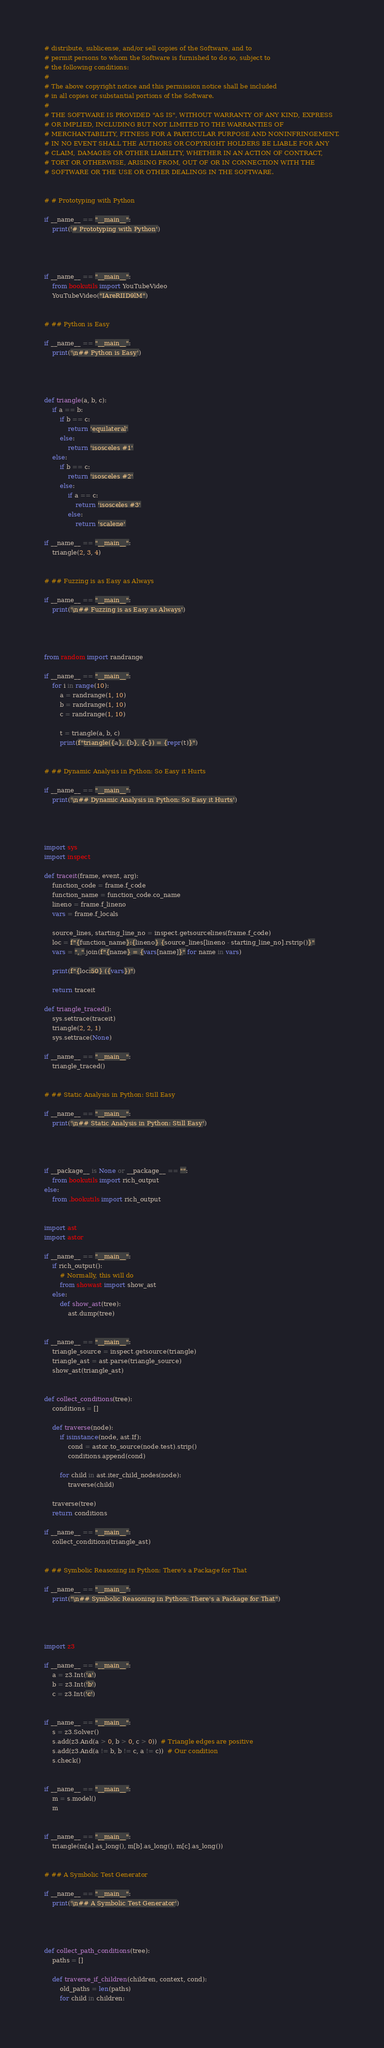<code> <loc_0><loc_0><loc_500><loc_500><_Python_># distribute, sublicense, and/or sell copies of the Software, and to
# permit persons to whom the Software is furnished to do so, subject to
# the following conditions:
#
# The above copyright notice and this permission notice shall be included
# in all copies or substantial portions of the Software.
#
# THE SOFTWARE IS PROVIDED "AS IS", WITHOUT WARRANTY OF ANY KIND, EXPRESS
# OR IMPLIED, INCLUDING BUT NOT LIMITED TO THE WARRANTIES OF
# MERCHANTABILITY, FITNESS FOR A PARTICULAR PURPOSE AND NONINFRINGEMENT.
# IN NO EVENT SHALL THE AUTHORS OR COPYRIGHT HOLDERS BE LIABLE FOR ANY
# CLAIM, DAMAGES OR OTHER LIABILITY, WHETHER IN AN ACTION OF CONTRACT,
# TORT OR OTHERWISE, ARISING FROM, OUT OF OR IN CONNECTION WITH THE
# SOFTWARE OR THE USE OR OTHER DEALINGS IN THE SOFTWARE.


# # Prototyping with Python

if __name__ == "__main__":
    print('# Prototyping with Python')




if __name__ == "__main__":
    from bookutils import YouTubeVideo
    YouTubeVideo("IAreRIID9lM")


# ## Python is Easy

if __name__ == "__main__":
    print('\n## Python is Easy')




def triangle(a, b, c):
    if a == b:
        if b == c:
            return 'equilateral'
        else:
            return 'isosceles #1'
    else:
        if b == c:
            return 'isosceles #2'
        else:
            if a == c:
                return 'isosceles #3'
            else:
                return 'scalene'

if __name__ == "__main__":
    triangle(2, 3, 4)


# ## Fuzzing is as Easy as Always

if __name__ == "__main__":
    print('\n## Fuzzing is as Easy as Always')




from random import randrange

if __name__ == "__main__":
    for i in range(10):
        a = randrange(1, 10)
        b = randrange(1, 10)
        c = randrange(1, 10)

        t = triangle(a, b, c)
        print(f"triangle({a}, {b}, {c}) = {repr(t)}")


# ## Dynamic Analysis in Python: So Easy it Hurts

if __name__ == "__main__":
    print('\n## Dynamic Analysis in Python: So Easy it Hurts')




import sys
import inspect

def traceit(frame, event, arg):
    function_code = frame.f_code
    function_name = function_code.co_name
    lineno = frame.f_lineno
    vars = frame.f_locals

    source_lines, starting_line_no = inspect.getsourcelines(frame.f_code)
    loc = f"{function_name}:{lineno} {source_lines[lineno - starting_line_no].rstrip()}"
    vars = ", ".join(f"{name} = {vars[name]}" for name in vars)

    print(f"{loc:50} ({vars})")

    return traceit

def triangle_traced():
    sys.settrace(traceit)
    triangle(2, 2, 1)
    sys.settrace(None)

if __name__ == "__main__":
    triangle_traced()


# ## Static Analysis in Python: Still Easy

if __name__ == "__main__":
    print('\n## Static Analysis in Python: Still Easy')




if __package__ is None or __package__ == "":
    from bookutils import rich_output
else:
    from .bookutils import rich_output


import ast
import astor

if __name__ == "__main__":
    if rich_output():
        # Normally, this will do
        from showast import show_ast
    else:
        def show_ast(tree):
            ast.dump(tree)


if __name__ == "__main__":
    triangle_source = inspect.getsource(triangle)
    triangle_ast = ast.parse(triangle_source)
    show_ast(triangle_ast)


def collect_conditions(tree):
    conditions = []

    def traverse(node):
        if isinstance(node, ast.If):
            cond = astor.to_source(node.test).strip()
            conditions.append(cond)

        for child in ast.iter_child_nodes(node):
            traverse(child)

    traverse(tree)
    return conditions

if __name__ == "__main__":
    collect_conditions(triangle_ast)


# ## Symbolic Reasoning in Python: There's a Package for That

if __name__ == "__main__":
    print("\n## Symbolic Reasoning in Python: There's a Package for That")




import z3

if __name__ == "__main__":
    a = z3.Int('a')
    b = z3.Int('b')
    c = z3.Int('c')


if __name__ == "__main__":
    s = z3.Solver()
    s.add(z3.And(a > 0, b > 0, c > 0))  # Triangle edges are positive
    s.add(z3.And(a != b, b != c, a != c))  # Our condition
    s.check()


if __name__ == "__main__":
    m = s.model()
    m


if __name__ == "__main__":
    triangle(m[a].as_long(), m[b].as_long(), m[c].as_long())


# ## A Symbolic Test Generator

if __name__ == "__main__":
    print('\n## A Symbolic Test Generator')




def collect_path_conditions(tree):
    paths = []

    def traverse_if_children(children, context, cond):
        old_paths = len(paths)
        for child in children:</code> 